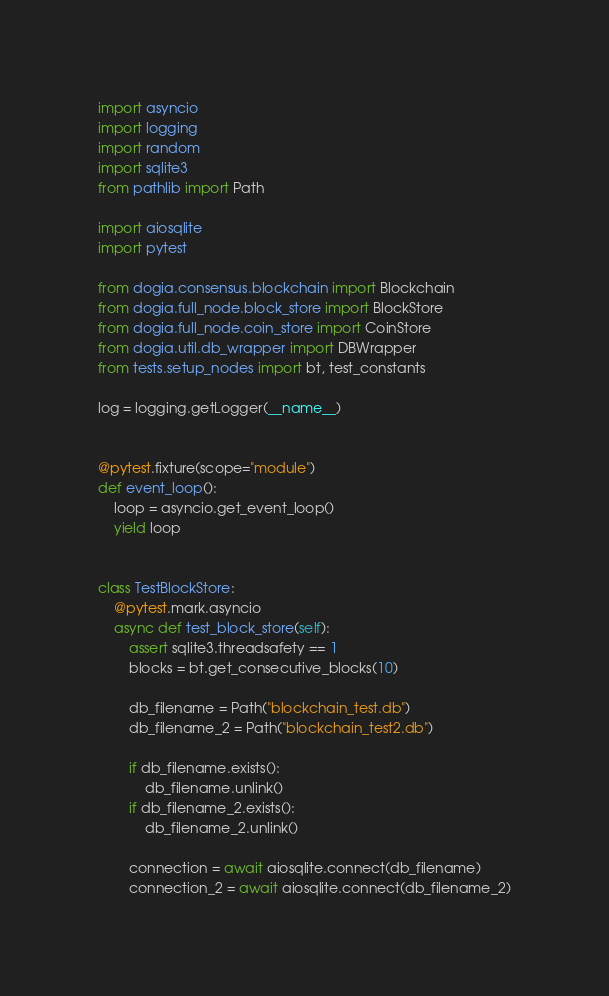Convert code to text. <code><loc_0><loc_0><loc_500><loc_500><_Python_>import asyncio
import logging
import random
import sqlite3
from pathlib import Path

import aiosqlite
import pytest

from dogia.consensus.blockchain import Blockchain
from dogia.full_node.block_store import BlockStore
from dogia.full_node.coin_store import CoinStore
from dogia.util.db_wrapper import DBWrapper
from tests.setup_nodes import bt, test_constants

log = logging.getLogger(__name__)


@pytest.fixture(scope="module")
def event_loop():
    loop = asyncio.get_event_loop()
    yield loop


class TestBlockStore:
    @pytest.mark.asyncio
    async def test_block_store(self):
        assert sqlite3.threadsafety == 1
        blocks = bt.get_consecutive_blocks(10)

        db_filename = Path("blockchain_test.db")
        db_filename_2 = Path("blockchain_test2.db")

        if db_filename.exists():
            db_filename.unlink()
        if db_filename_2.exists():
            db_filename_2.unlink()

        connection = await aiosqlite.connect(db_filename)
        connection_2 = await aiosqlite.connect(db_filename_2)</code> 